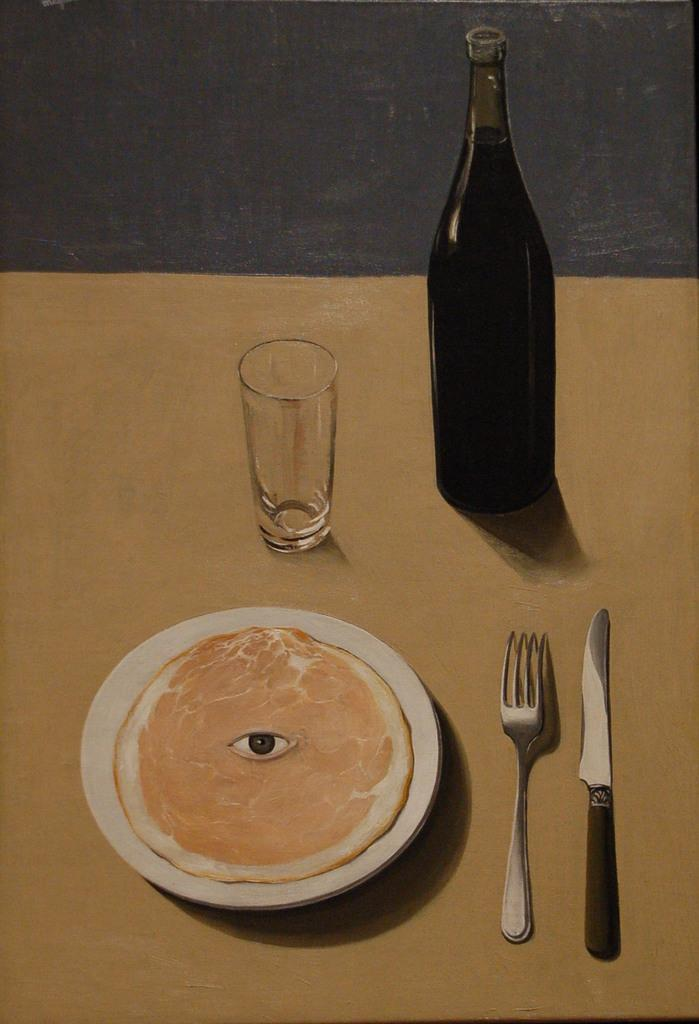What is present on the table in the image? There is a plate, food, a fork, a knife, a bottle, and a glass on the table in the image. What type of food is on the plate? The provided facts do not specify the type of food on the plate. What utensils are available for eating the food? There is a fork and a knife available for eating the food. What type of container is present for a beverage? There is a bottle and a glass present for a beverage. What type of sand is visible on the plate in the image? There is no sand visible on the plate in the image; it contains food. What word is written on the fork in the image? There is no word written on the fork in the image; it is a utensil for eating. 